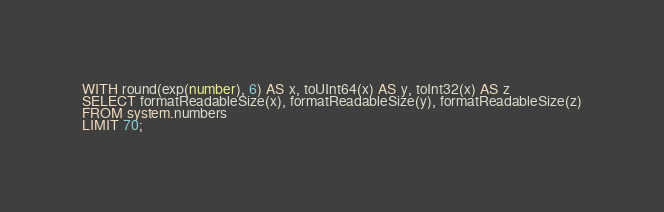<code> <loc_0><loc_0><loc_500><loc_500><_SQL_>WITH round(exp(number), 6) AS x, toUInt64(x) AS y, toInt32(x) AS z
SELECT formatReadableSize(x), formatReadableSize(y), formatReadableSize(z)
FROM system.numbers
LIMIT 70;
</code> 